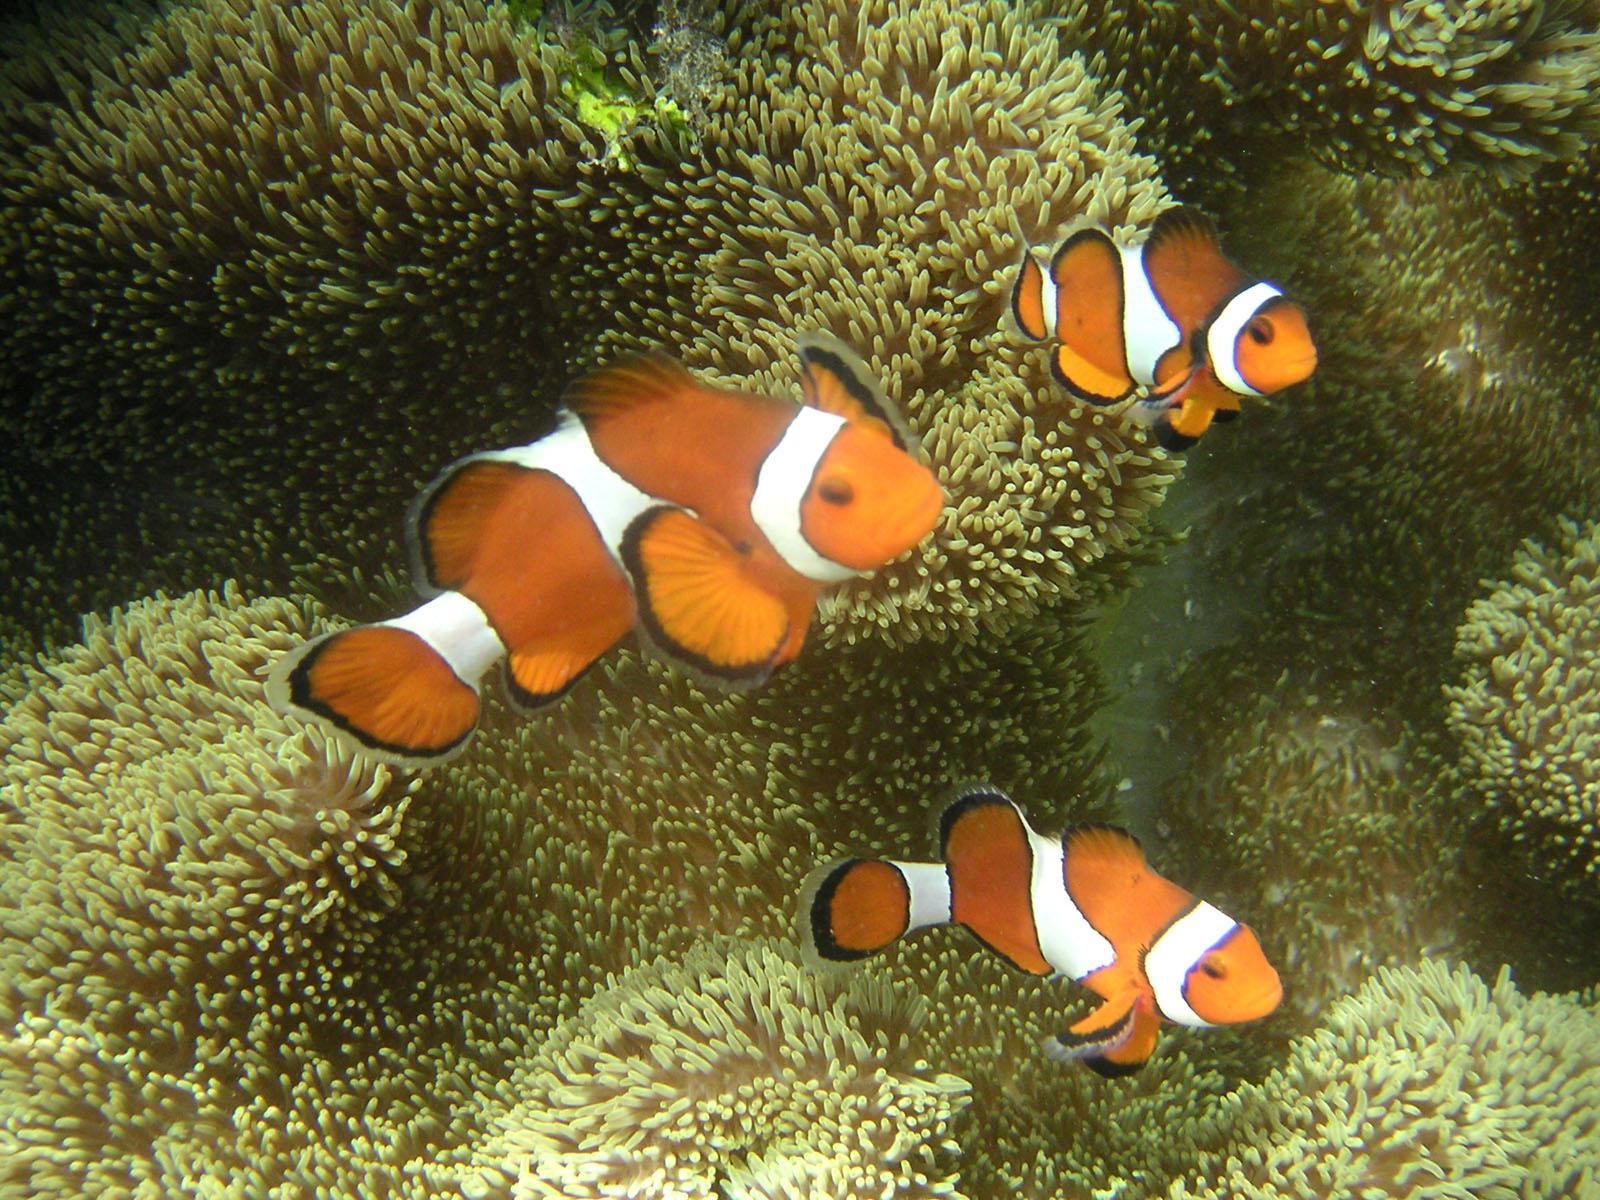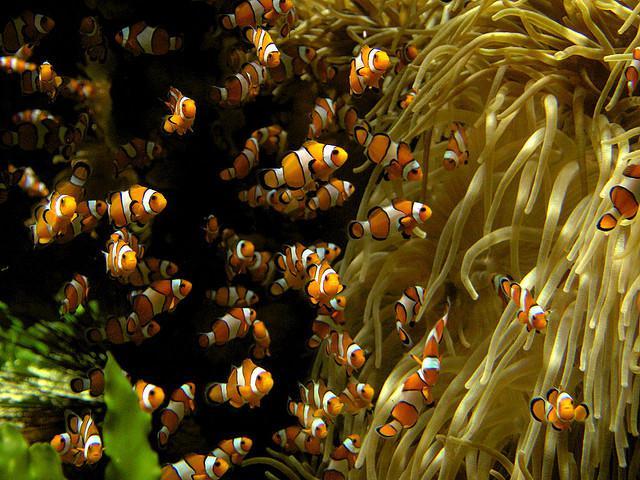The first image is the image on the left, the second image is the image on the right. Analyze the images presented: Is the assertion "There are 5 clownfish swimming." valid? Answer yes or no. No. 